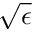Convert formula to latex. <formula><loc_0><loc_0><loc_500><loc_500>\sqrt { \epsilon }</formula> 